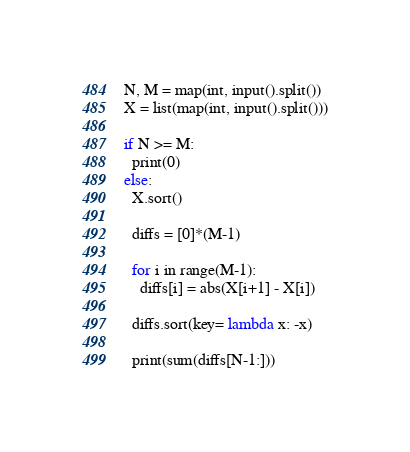Convert code to text. <code><loc_0><loc_0><loc_500><loc_500><_Python_>N, M = map(int, input().split())
X = list(map(int, input().split()))

if N >= M:
  print(0)
else:
  X.sort()

  diffs = [0]*(M-1)

  for i in range(M-1):
    diffs[i] = abs(X[i+1] - X[i])

  diffs.sort(key= lambda x: -x)

  print(sum(diffs[N-1:]))</code> 